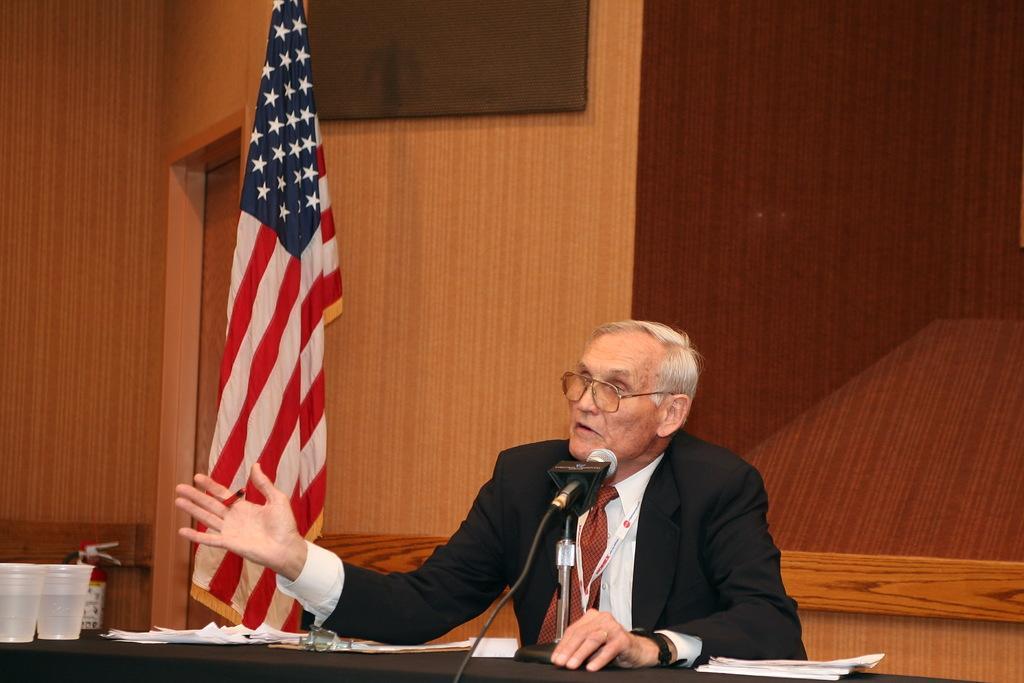How would you summarize this image in a sentence or two? In this image we can see a person sitting in front of the table, on the table there are papers, microphone, cups and few objects. In the background, we can see a flag near the wood wall and we can see the black color object attached to the wall and we can see a door. 